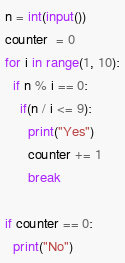<code> <loc_0><loc_0><loc_500><loc_500><_Python_>n = int(input())
counter  = 0
for i in range(1, 10):
  if n % i == 0:
    if(n / i <= 9):
      print("Yes")
      counter += 1
      break
  
if counter == 0:
  print("No")</code> 